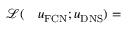Convert formula to latex. <formula><loc_0><loc_0><loc_500><loc_500>\begin{array} { r l } { \mathcal { L } ( } & u _ { F C N } ; u _ { D N S } ) = } \end{array}</formula> 